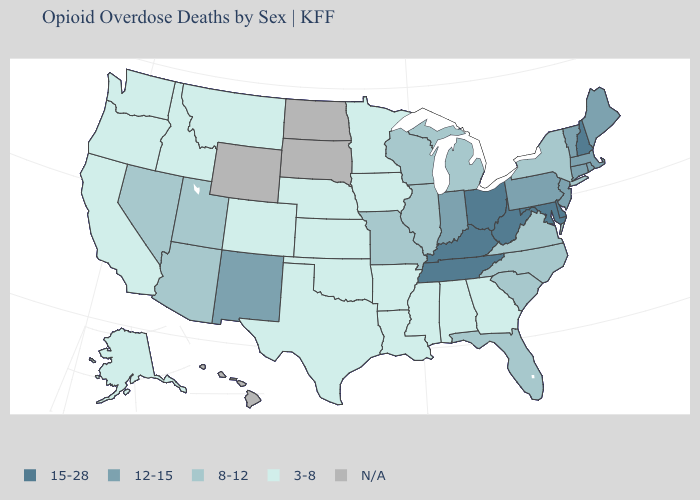Does New Mexico have the lowest value in the West?
Quick response, please. No. Does New Mexico have the highest value in the West?
Be succinct. Yes. What is the value of North Carolina?
Quick response, please. 8-12. Which states have the highest value in the USA?
Quick response, please. Delaware, Kentucky, Maryland, New Hampshire, Ohio, Tennessee, West Virginia. What is the value of Nebraska?
Concise answer only. 3-8. What is the lowest value in the MidWest?
Answer briefly. 3-8. Does the first symbol in the legend represent the smallest category?
Keep it brief. No. Does the map have missing data?
Answer briefly. Yes. What is the value of Virginia?
Answer briefly. 8-12. How many symbols are there in the legend?
Be succinct. 5. What is the value of Oklahoma?
Keep it brief. 3-8. Name the states that have a value in the range N/A?
Write a very short answer. Hawaii, North Dakota, South Dakota, Wyoming. 